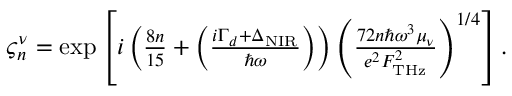<formula> <loc_0><loc_0><loc_500><loc_500>\begin{array} { r } { \varsigma _ { n } ^ { \nu } = \exp \left [ i \left ( \frac { 8 n } { 1 5 } + \left ( \frac { i \Gamma _ { d } + \Delta _ { N I R } } { \hbar { \omega } } \right ) \right ) \left ( \frac { 7 2 n \hbar { \omega } ^ { 3 } \mu _ { \nu } } { e ^ { 2 } F _ { T H z } ^ { 2 } } \right ) ^ { 1 / 4 } \right ] . } \end{array}</formula> 